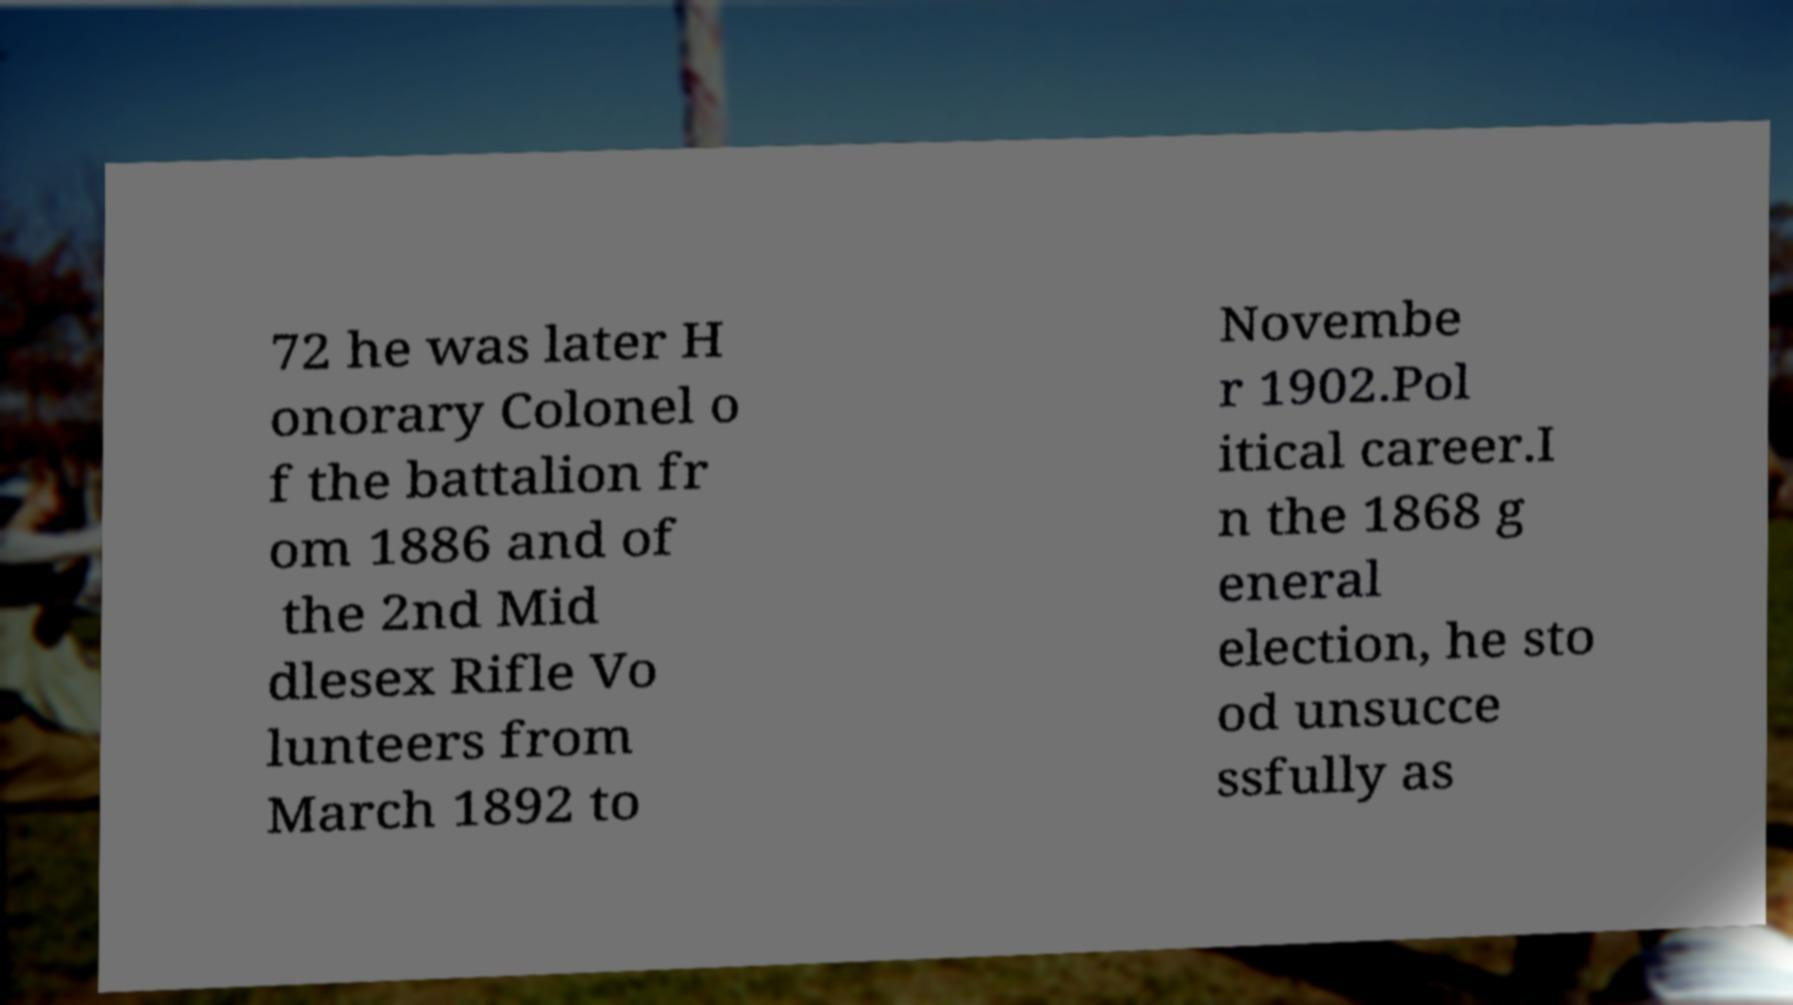Can you accurately transcribe the text from the provided image for me? 72 he was later H onorary Colonel o f the battalion fr om 1886 and of the 2nd Mid dlesex Rifle Vo lunteers from March 1892 to Novembe r 1902.Pol itical career.I n the 1868 g eneral election, he sto od unsucce ssfully as 